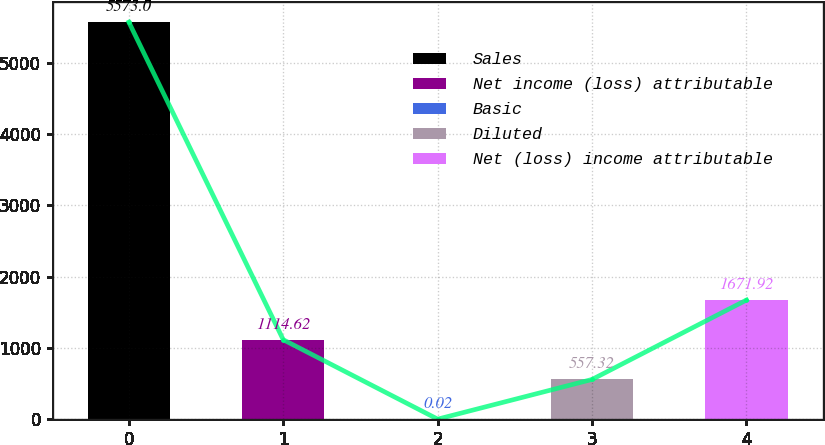Convert chart to OTSL. <chart><loc_0><loc_0><loc_500><loc_500><bar_chart><fcel>Sales<fcel>Net income (loss) attributable<fcel>Basic<fcel>Diluted<fcel>Net (loss) income attributable<nl><fcel>5573<fcel>1114.62<fcel>0.02<fcel>557.32<fcel>1671.92<nl></chart> 